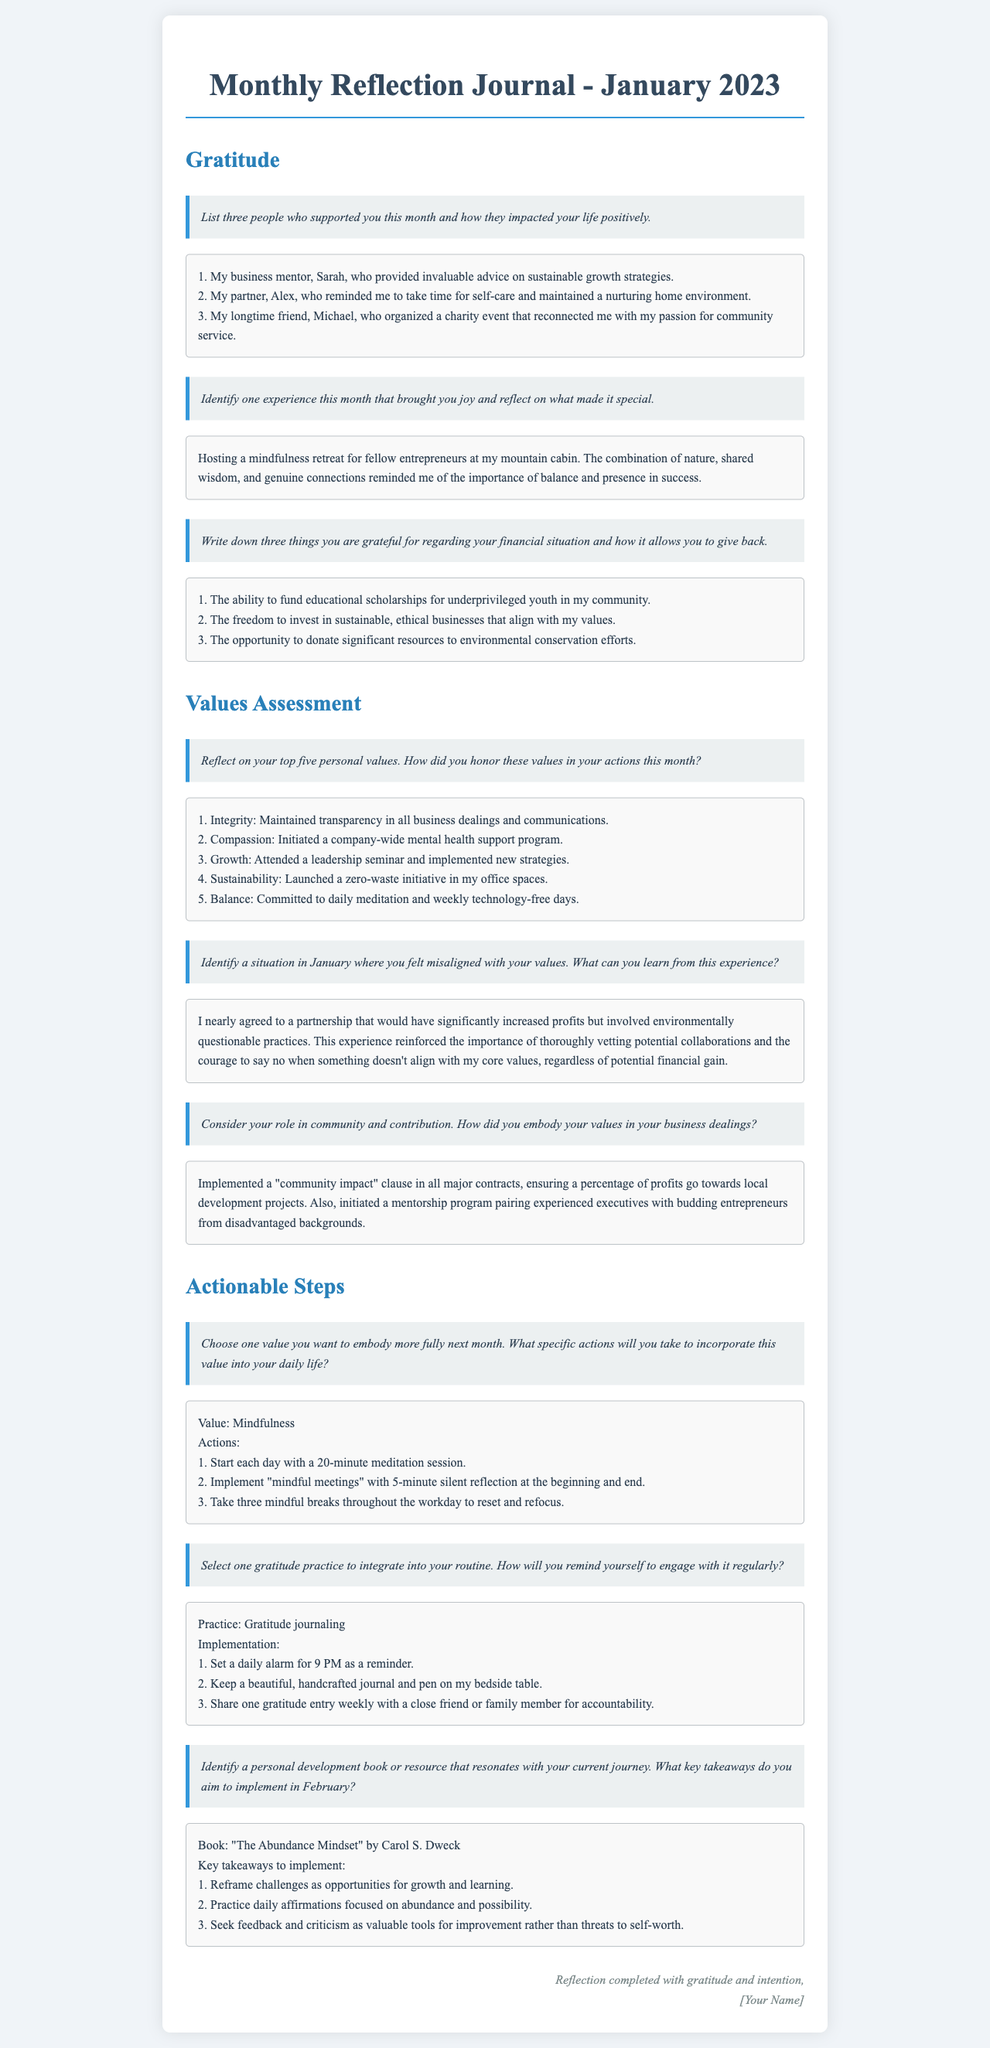what is the title of the document? The title appears at the top of the rendered document, stating the focus and time period for reflection.
Answer: Monthly Reflection Journal - January 2023 who is mentioned as a business mentor? The response under gratitude lists a business mentor who provided advice.
Answer: Sarah how many people were supported according to the gratitude section? The gratitude section requests the reflection on three individuals who provided support.
Answer: Three what was the experience that brought joy this month? The question regarding joy specifically asks for a singular joyful experience.
Answer: Hosting a mindfulness retreat which value was planned to be embodied more fully next month? The actionable steps section specifies the value chosen for focus in the following month.
Answer: Mindfulness name one book mentioned in the actionable steps section. The actionable steps include a personal development book that reflects the current journey.
Answer: The Abundance Mindset how many financial situations are listed in gratitude? The gratitude section explicitly asks for a list related to three aspects of financial gratitude.
Answer: Three what specific actions are suggested for incorporating mindfulness? The response under actionable steps outlines concrete actions for embracing a value.
Answer: Start each day with a 20-minute meditation session what initiative was launched in the values assessment section? The values assessment notes a specific effort to promote environmentally friendly practices at work.
Answer: A zero-waste initiative 